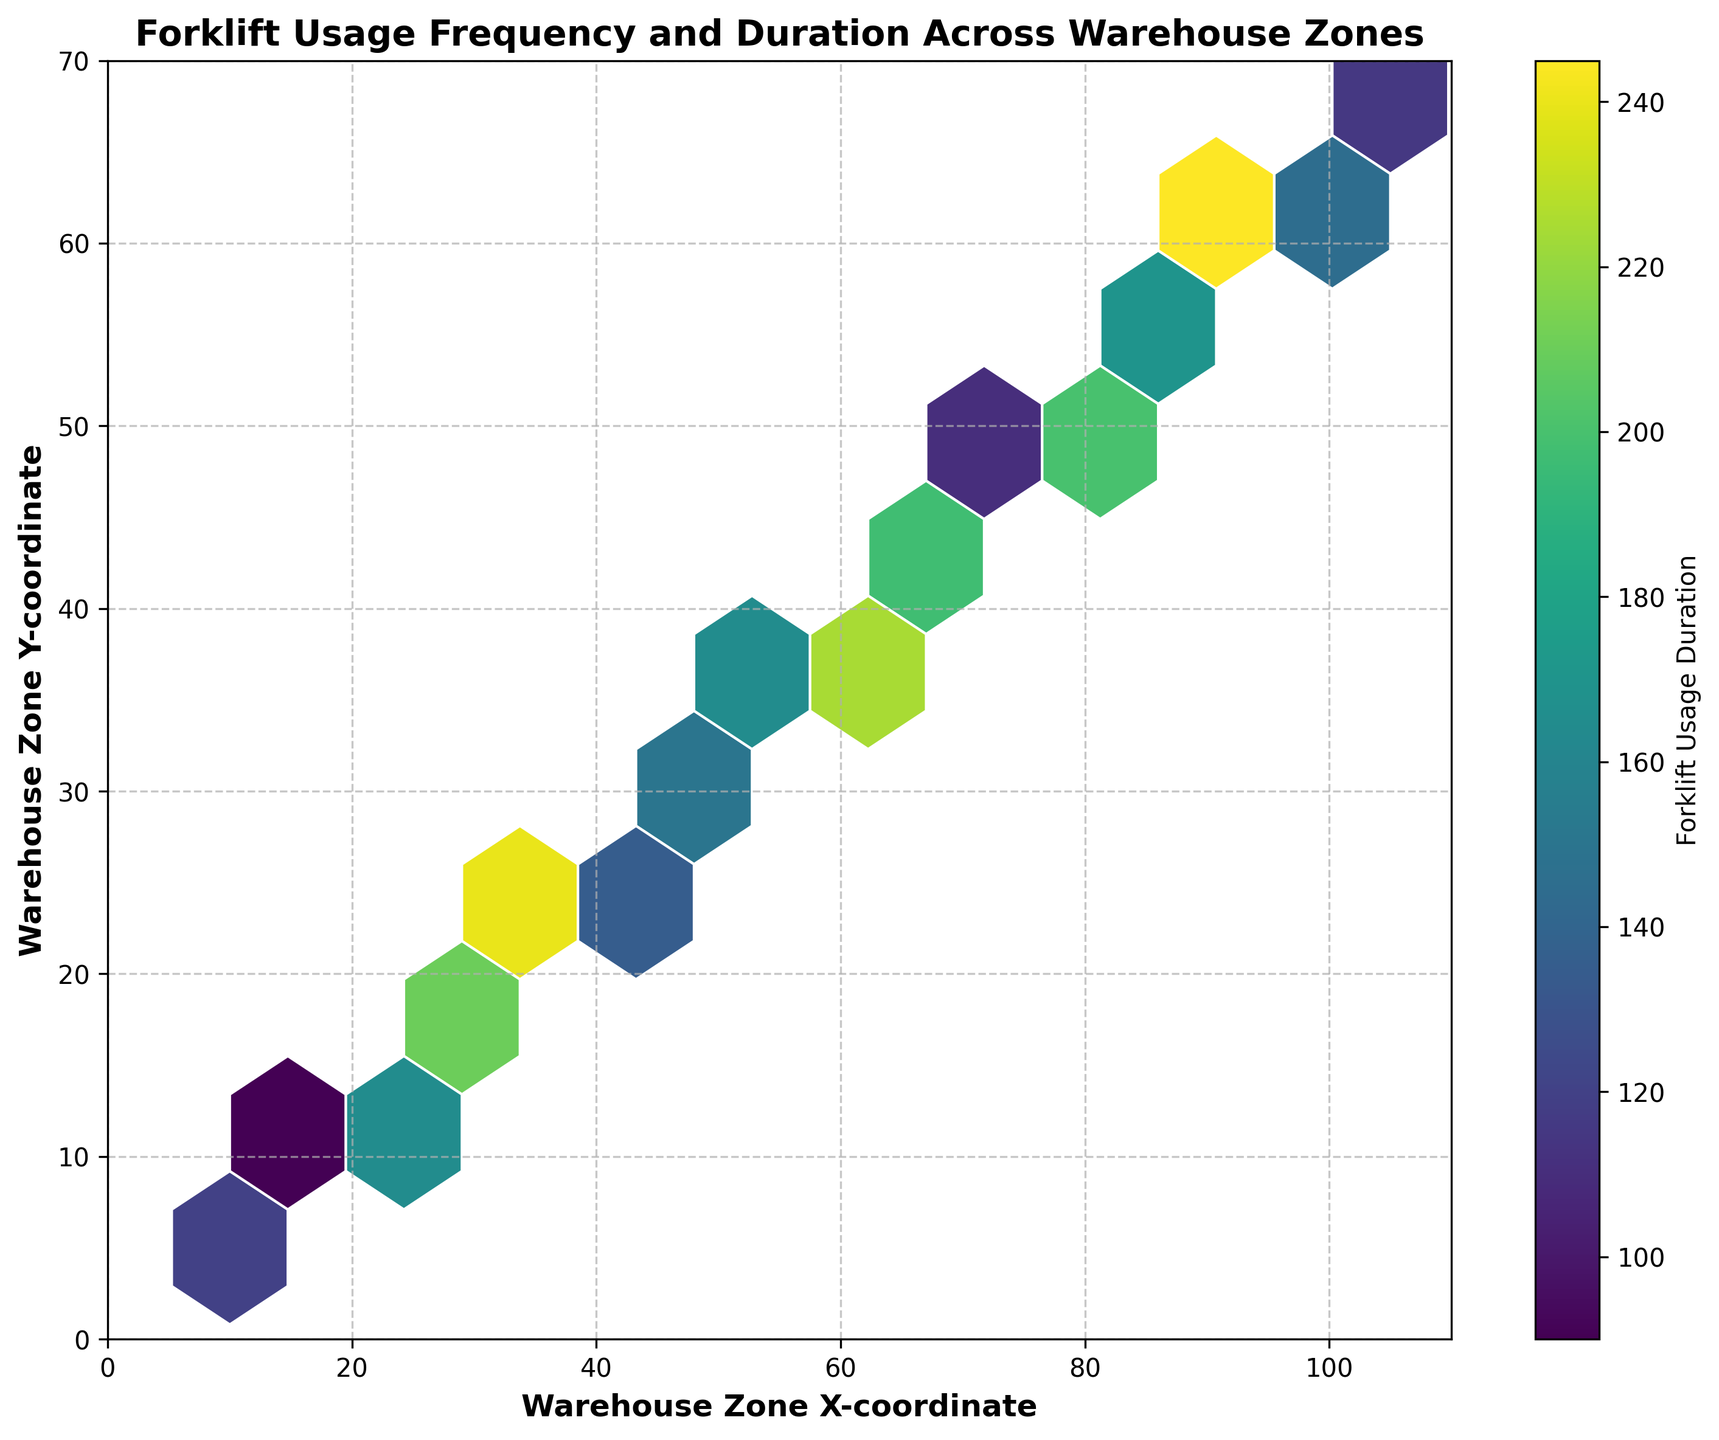What's the title of the plot? The title of the plot is usually located at the top of the figure. It provides a summary of what the plot is about. In this case, it's "Forklift Usage Frequency and Duration Across Warehouse Zones"
Answer: Forklift Usage Frequency and Duration Across Warehouse Zones What do the x and y axes represent on the plot? The labels on the x and y axes define what the axes represent. The x-axis represents "Warehouse Zone X-coordinate," and the y-axis represents "Warehouse Zone Y-coordinate."
Answer: Warehouse Zone X-coordinate and Warehouse Zone Y-coordinate How many bins are used to divide the data in the hexbin plot? In a hexbin plot, the grid size parameter determines the number of bins. Here, the grid size is 10, which means the data is divided into a 10x10 grid.
Answer: 10 In which region of the warehouse is the forklift usage duration the highest? The color intensity in a hexbin plot indicates the value of forklift usage duration. The brightest hexagons are where the duration is highest. In this plot, the top-right region has the highest color intensity, indicating the highest usage duration.
Answer: Top-right region How are the color intensities interpreted on the plot? The color bar on the right side of the plot indicates how colors map to usage duration values. Darker colors represent lower forklift usage durations, and lighter colors represent higher durations.
Answer: Darker colors for lower usage, lighter colors for higher usage What is the approximate duration of forklift usage in the zone with x=20 and y=12? Locate the hexagon where x=20 and y=12. The color fills denote the duration, cross-referenced with the color bar. At these coordinates, the color corresponds to a duration value of 180.
Answer: 180 Which zone has more significant forklift usage duration: the zone with coordinates (40, 25) or (45, 28)? Compare the color intensities of the two hexagons at the specific coordinates. The zone with coordinates (40, 25) has a higher color intensity than (45, 28), indicating a longer duration of forklift usage.
Answer: (40, 25) What is the range of the x-axis and y-axis in the plot? The plot's boundaries are marked on the x-axis and y-axis. The x-axis ranges from 0 to 110, and the y-axis ranges from 0 to 70.
Answer: x-axis: 0-110, y-axis: 0-70 If you sum the forklift usage durations for zones with x=30, y=18, and x=55, y=35, what do you get? Find the durations for the given coordinates: x=30, y=18 has a duration of 210, and x=55, y=35 has a duration of 165. Sum them up: 210 + 165 = 375.
Answer: 375 Between zones with coordinates (65, 42) and (95, 62), which one has lesser forklift usage duration? Check the two hexagons: (65, 42) has a duration associated with a lighter color (255), and (95, 62) has an even lighter color (260). Comparing these, the zone (65, 42) has lesser fork duration.
Answer: (65, 42) 